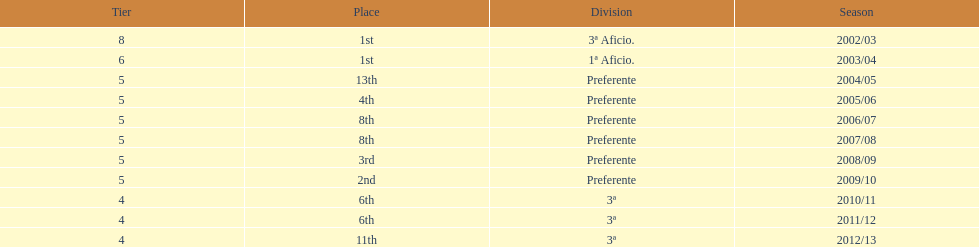How long did the team stay in first place? 2 years. 